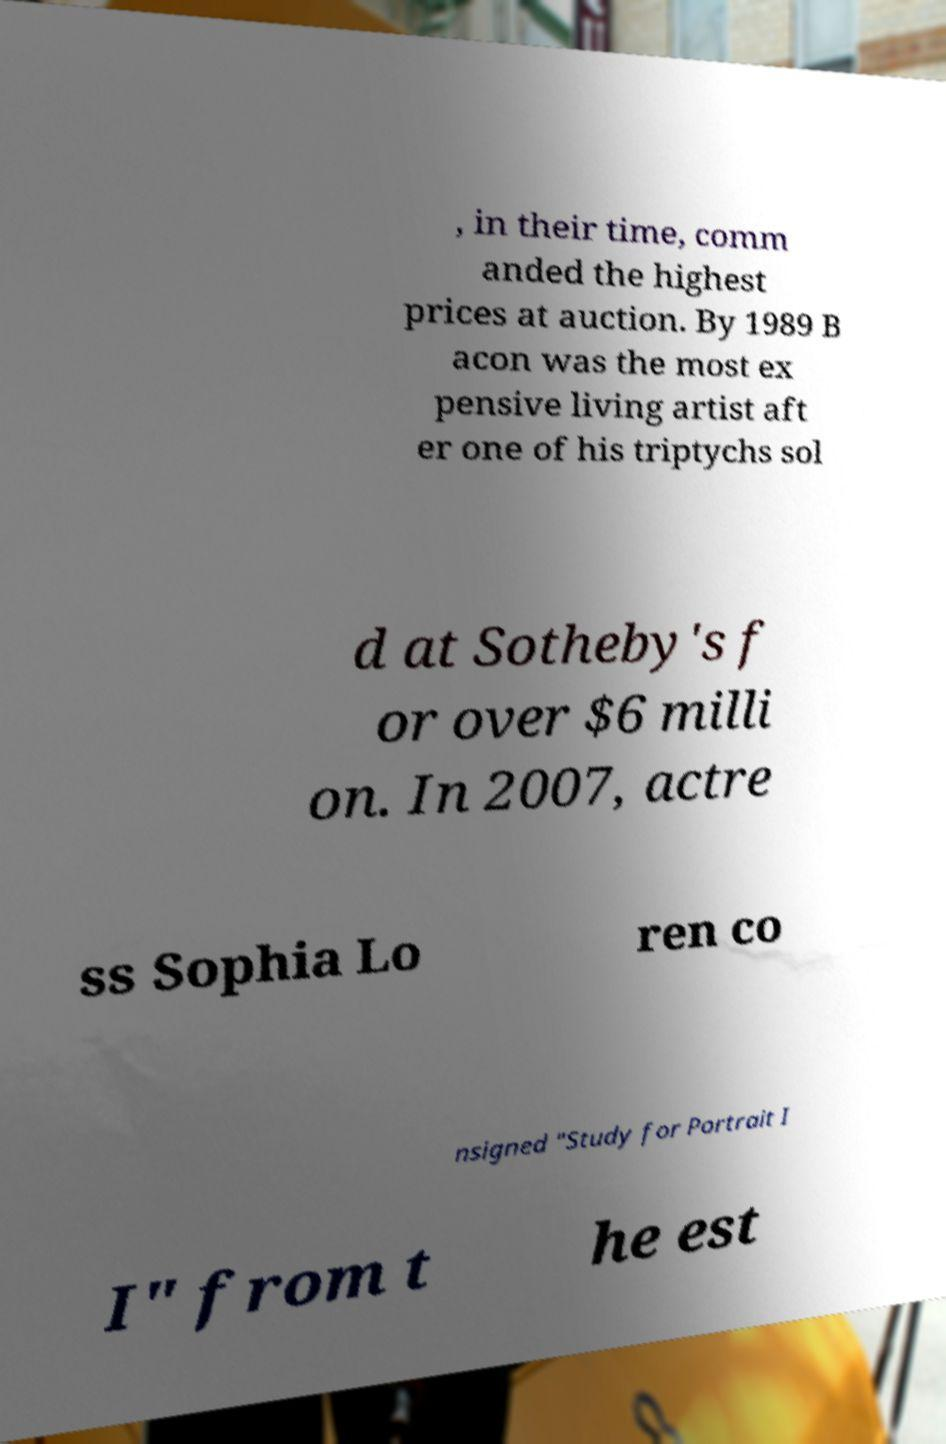Please identify and transcribe the text found in this image. , in their time, comm anded the highest prices at auction. By 1989 B acon was the most ex pensive living artist aft er one of his triptychs sol d at Sotheby's f or over $6 milli on. In 2007, actre ss Sophia Lo ren co nsigned "Study for Portrait I I" from t he est 